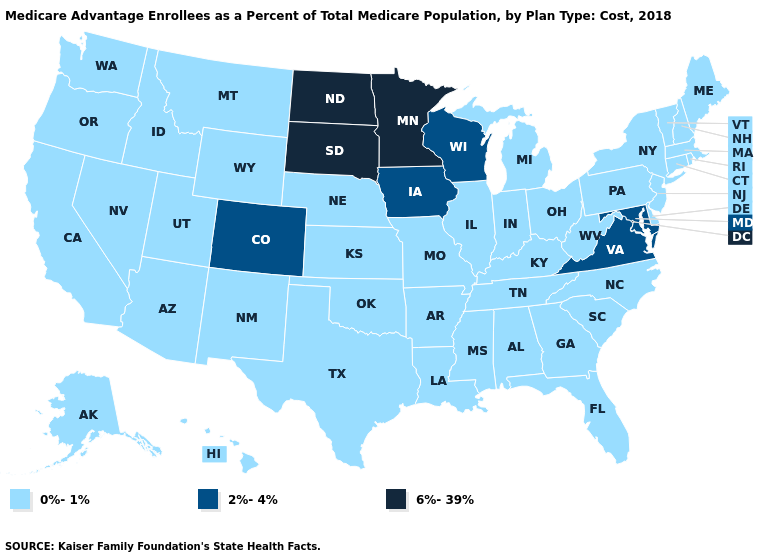Name the states that have a value in the range 6%-39%?
Keep it brief. Minnesota, North Dakota, South Dakota. Which states hav the highest value in the West?
Short answer required. Colorado. What is the highest value in the USA?
Be succinct. 6%-39%. Does Colorado have a lower value than North Dakota?
Keep it brief. Yes. What is the value of Iowa?
Answer briefly. 2%-4%. What is the value of Wyoming?
Answer briefly. 0%-1%. Does Nebraska have the highest value in the MidWest?
Give a very brief answer. No. Does Maryland have the highest value in the South?
Write a very short answer. Yes. What is the value of Georgia?
Concise answer only. 0%-1%. What is the highest value in the USA?
Answer briefly. 6%-39%. What is the value of North Carolina?
Quick response, please. 0%-1%. What is the lowest value in the USA?
Concise answer only. 0%-1%. Among the states that border Wyoming , which have the highest value?
Concise answer only. South Dakota. Does Louisiana have the same value as Colorado?
Write a very short answer. No. Name the states that have a value in the range 0%-1%?
Write a very short answer. Alabama, Alaska, Arizona, Arkansas, California, Connecticut, Delaware, Florida, Georgia, Hawaii, Idaho, Illinois, Indiana, Kansas, Kentucky, Louisiana, Maine, Massachusetts, Michigan, Mississippi, Missouri, Montana, Nebraska, Nevada, New Hampshire, New Jersey, New Mexico, New York, North Carolina, Ohio, Oklahoma, Oregon, Pennsylvania, Rhode Island, South Carolina, Tennessee, Texas, Utah, Vermont, Washington, West Virginia, Wyoming. 